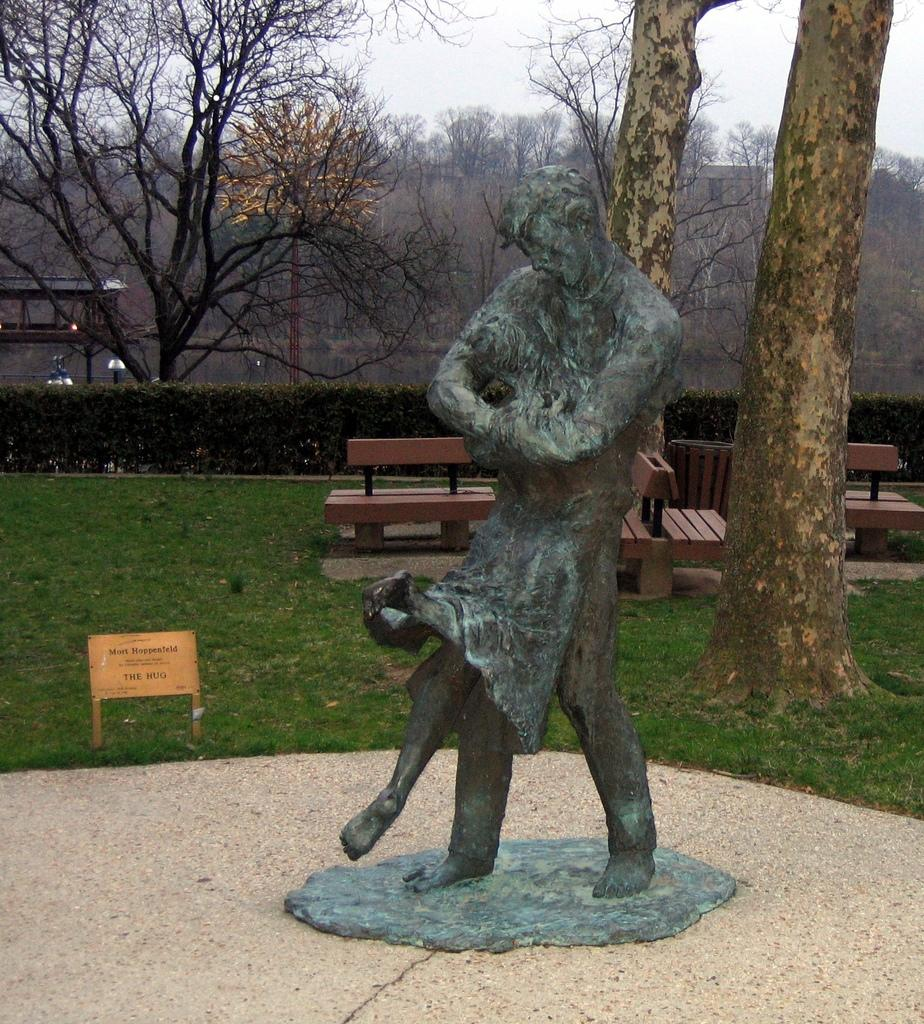What is the main subject in the center of the image? There is a statue in the center of the image. What type of terrain is visible in the center of the image? There is grass land in the center of the image. What type of seating is available in the center of the image? There are benches in the center of the image. What can be seen in the background of the image? There are trees in the background of the image. What type of table is used for the statue's operation in the image? There is no table or operation associated with the statue in the image; it is a stationary object. 